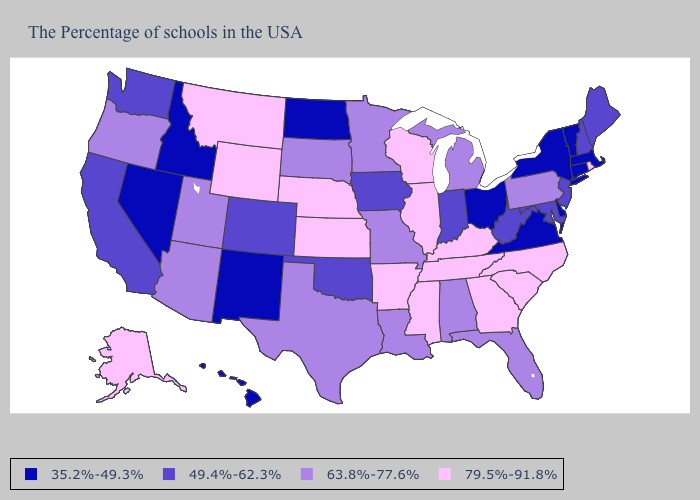How many symbols are there in the legend?
Keep it brief. 4. Does Mississippi have a lower value than Nevada?
Write a very short answer. No. What is the value of Hawaii?
Quick response, please. 35.2%-49.3%. Does South Carolina have a higher value than New Mexico?
Short answer required. Yes. Which states have the lowest value in the West?
Write a very short answer. New Mexico, Idaho, Nevada, Hawaii. Which states have the lowest value in the USA?
Concise answer only. Massachusetts, Vermont, Connecticut, New York, Delaware, Virginia, Ohio, North Dakota, New Mexico, Idaho, Nevada, Hawaii. Does Delaware have the lowest value in the USA?
Short answer required. Yes. Among the states that border Georgia , does Florida have the lowest value?
Be succinct. Yes. Among the states that border Wyoming , does Idaho have the lowest value?
Write a very short answer. Yes. Does California have the highest value in the West?
Answer briefly. No. What is the lowest value in the South?
Answer briefly. 35.2%-49.3%. Is the legend a continuous bar?
Quick response, please. No. What is the lowest value in the USA?
Give a very brief answer. 35.2%-49.3%. Among the states that border Wyoming , does Montana have the highest value?
Quick response, please. Yes. Name the states that have a value in the range 79.5%-91.8%?
Quick response, please. Rhode Island, North Carolina, South Carolina, Georgia, Kentucky, Tennessee, Wisconsin, Illinois, Mississippi, Arkansas, Kansas, Nebraska, Wyoming, Montana, Alaska. 